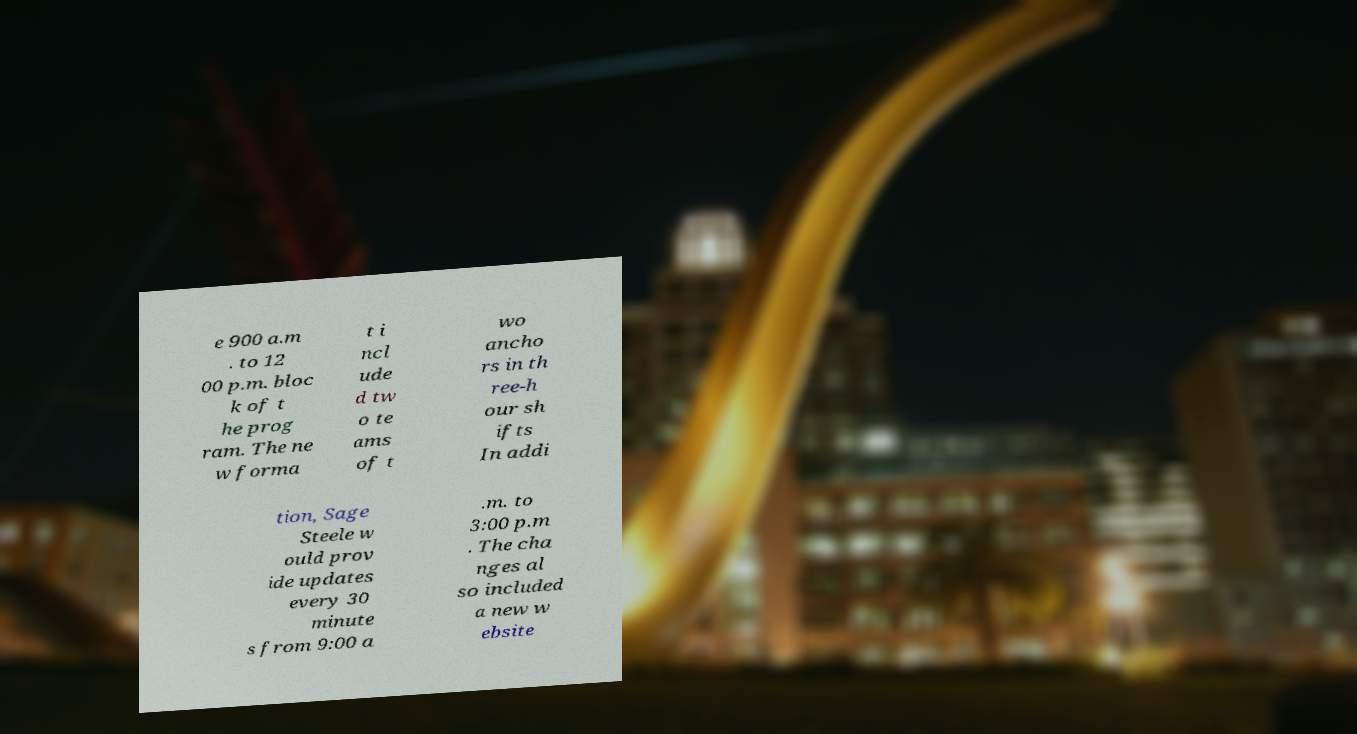I need the written content from this picture converted into text. Can you do that? e 900 a.m . to 12 00 p.m. bloc k of t he prog ram. The ne w forma t i ncl ude d tw o te ams of t wo ancho rs in th ree-h our sh ifts In addi tion, Sage Steele w ould prov ide updates every 30 minute s from 9:00 a .m. to 3:00 p.m . The cha nges al so included a new w ebsite 